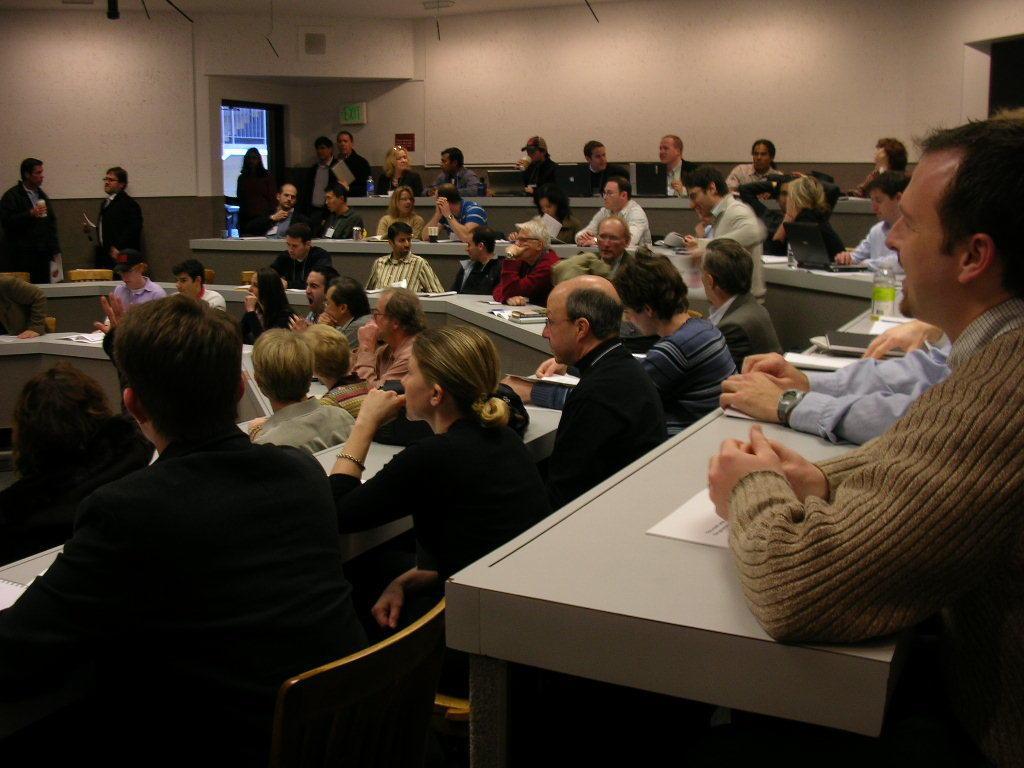Can you describe this image briefly? In the classroom there are many people sitting. In front of them there is a bench. There are some papers, glasses, bottle, laptop. They are sitting on the chairs. To the top left corner there are two people standing and talking. And to the entrance there is a lady standing. 